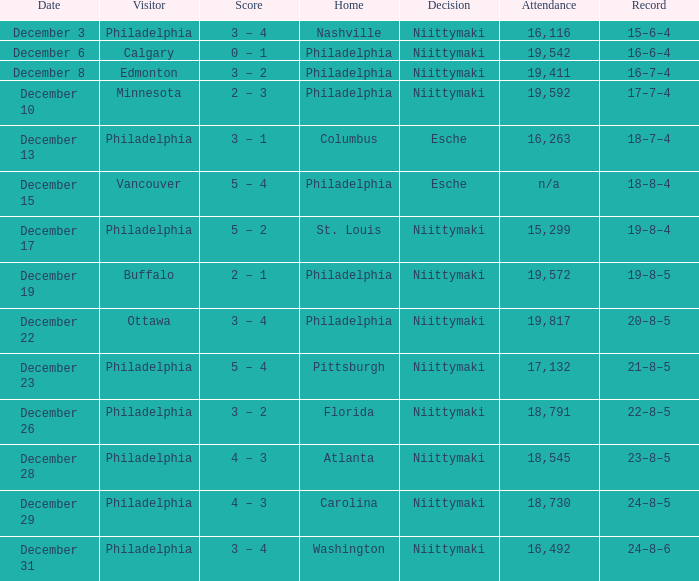What was the decision when the attendance was 19,592? Niittymaki. 